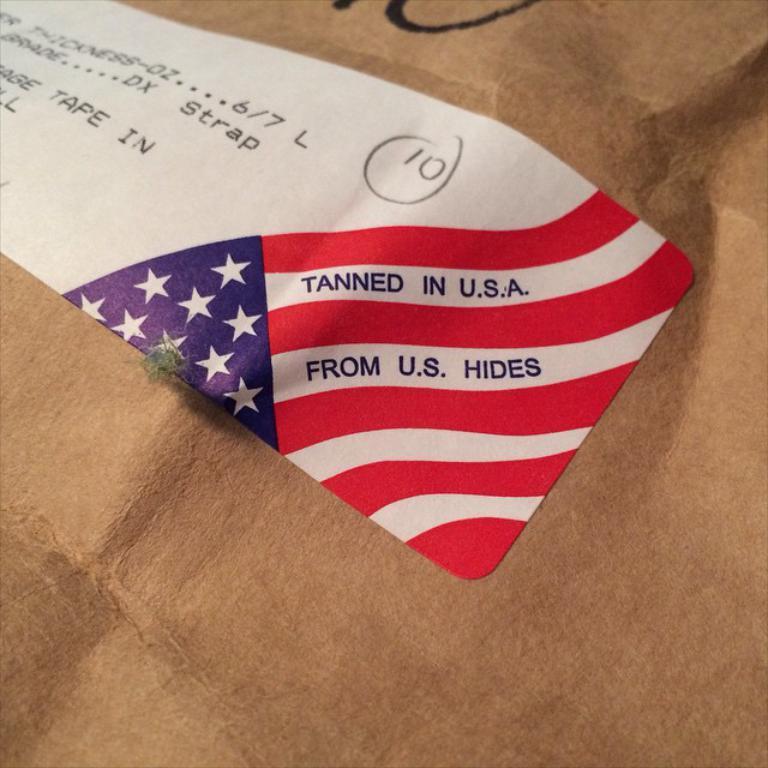Where was this package tanned at?
Ensure brevity in your answer.  U.s.a. 